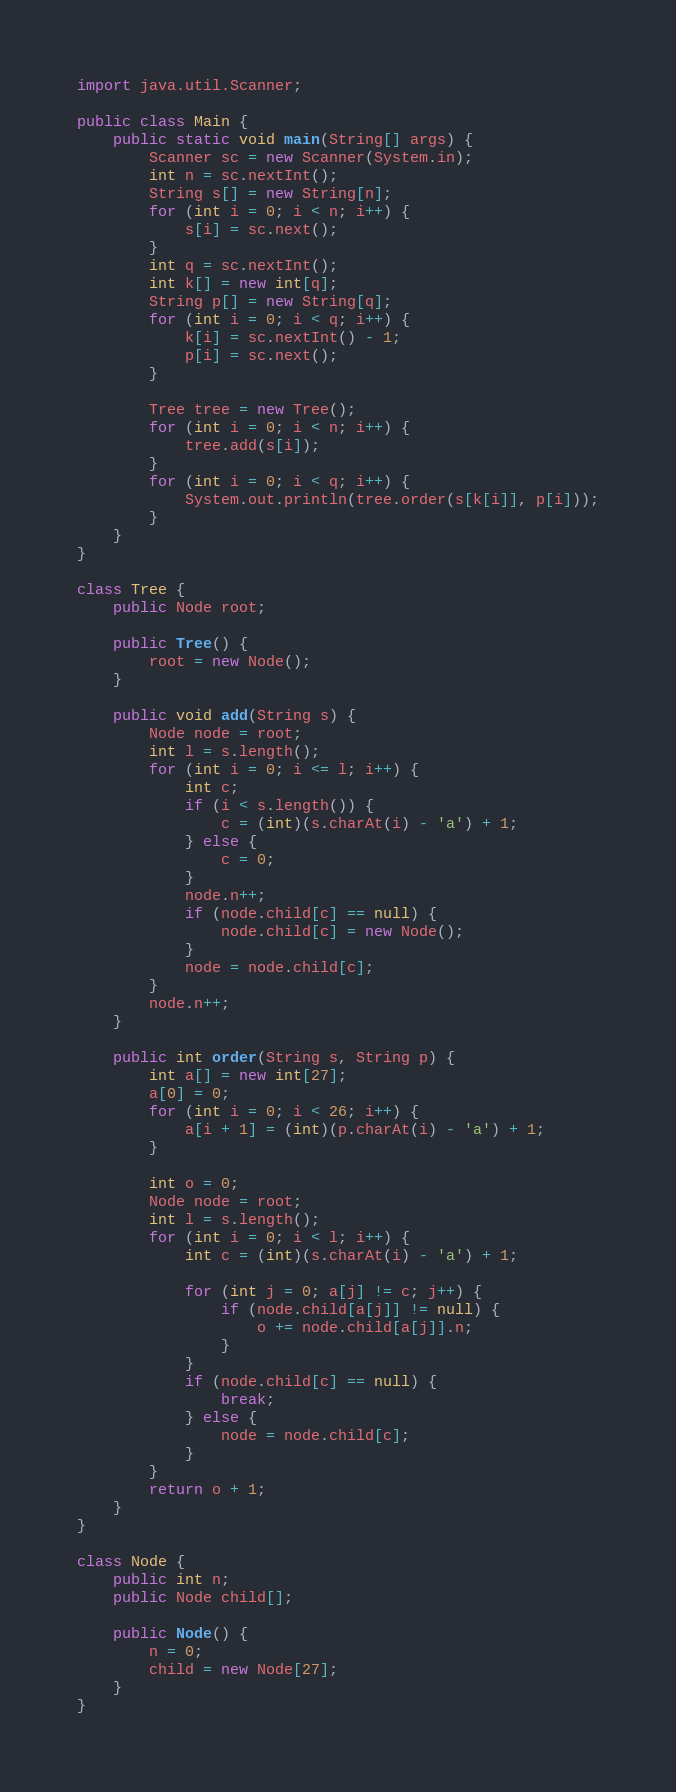Convert code to text. <code><loc_0><loc_0><loc_500><loc_500><_Java_>import java.util.Scanner;

public class Main {
	public static void main(String[] args) {
		Scanner sc = new Scanner(System.in);
		int n = sc.nextInt();
		String s[] = new String[n];
		for (int i = 0; i < n; i++) {
			s[i] = sc.next();
		}
		int q = sc.nextInt();
		int k[] = new int[q];
		String p[] = new String[q];
		for (int i = 0; i < q; i++) {
			k[i] = sc.nextInt() - 1;
			p[i] = sc.next();
		}

		Tree tree = new Tree();
		for (int i = 0; i < n; i++) {
			tree.add(s[i]);
		}
		for (int i = 0; i < q; i++) {
			System.out.println(tree.order(s[k[i]], p[i]));
		}
	}
}

class Tree {
	public Node root;

	public Tree() {
		root = new Node();
	}

	public void add(String s) {
		Node node = root;
		int l = s.length();
		for (int i = 0; i <= l; i++) {
			int c;
			if (i < s.length()) {
				c = (int)(s.charAt(i) - 'a') + 1;
			} else {
				c = 0;
			}
			node.n++;
			if (node.child[c] == null) {
				node.child[c] = new Node();
			}
			node = node.child[c];
		}
		node.n++;
	}

	public int order(String s, String p) {
		int a[] = new int[27];
		a[0] = 0;
		for (int i = 0; i < 26; i++) {
			a[i + 1] = (int)(p.charAt(i) - 'a') + 1;
		}

		int o = 0;
		Node node = root;
		int l = s.length();
		for (int i = 0; i < l; i++) {
			int c = (int)(s.charAt(i) - 'a') + 1;

			for (int j = 0; a[j] != c; j++) {
				if (node.child[a[j]] != null) {
					o += node.child[a[j]].n;
				}
			}
			if (node.child[c] == null) {
				break;
			} else {
				node = node.child[c];
			}
		}
		return o + 1;
	}
}

class Node {
	public int n;
	public Node child[];

	public Node() {
		n = 0;
		child = new Node[27];
	}
}
</code> 